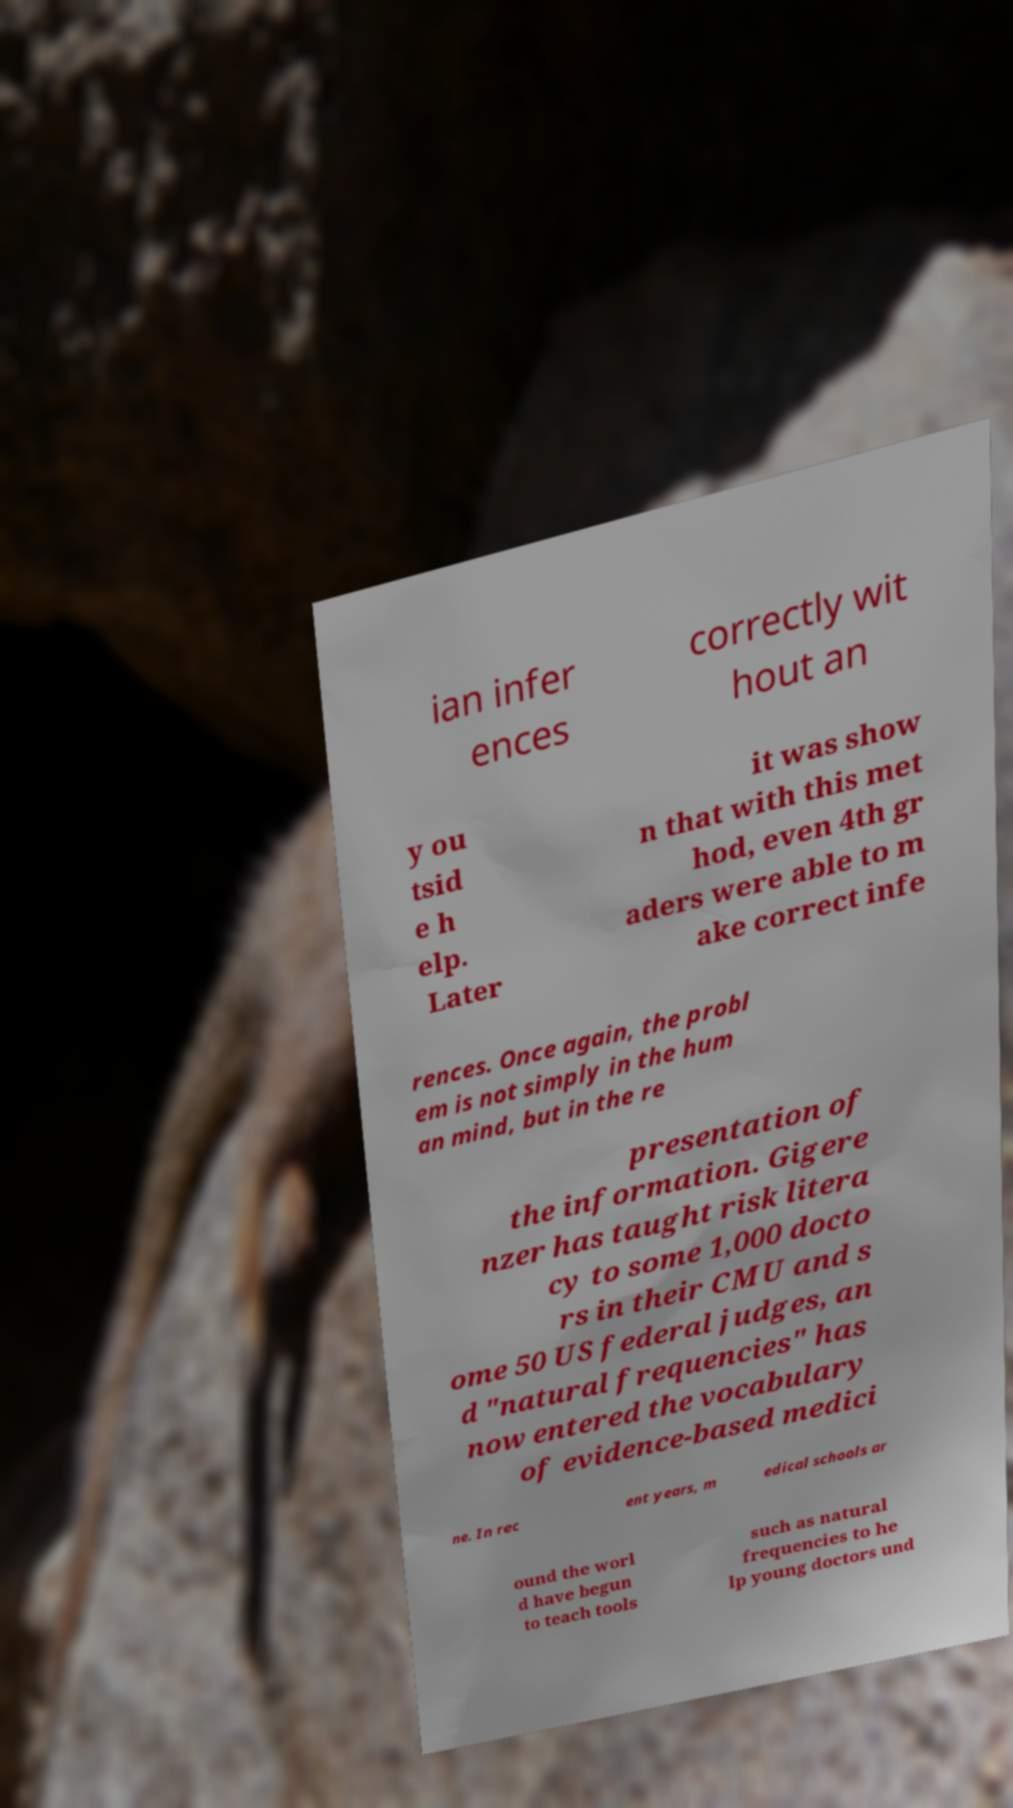For documentation purposes, I need the text within this image transcribed. Could you provide that? ian infer ences correctly wit hout an y ou tsid e h elp. Later it was show n that with this met hod, even 4th gr aders were able to m ake correct infe rences. Once again, the probl em is not simply in the hum an mind, but in the re presentation of the information. Gigere nzer has taught risk litera cy to some 1,000 docto rs in their CMU and s ome 50 US federal judges, an d "natural frequencies" has now entered the vocabulary of evidence-based medici ne. In rec ent years, m edical schools ar ound the worl d have begun to teach tools such as natural frequencies to he lp young doctors und 